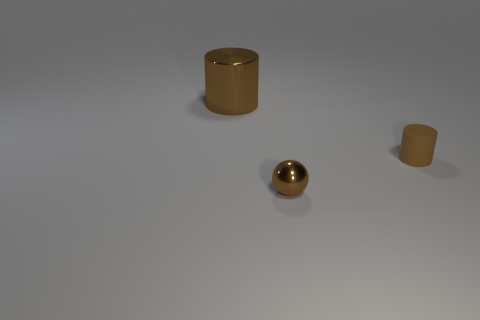Add 2 small rubber cylinders. How many objects exist? 5 Subtract all cylinders. How many objects are left? 1 Subtract 0 gray cubes. How many objects are left? 3 Subtract all tiny cylinders. Subtract all brown cylinders. How many objects are left? 0 Add 3 small brown shiny spheres. How many small brown shiny spheres are left? 4 Add 3 big cyan cubes. How many big cyan cubes exist? 3 